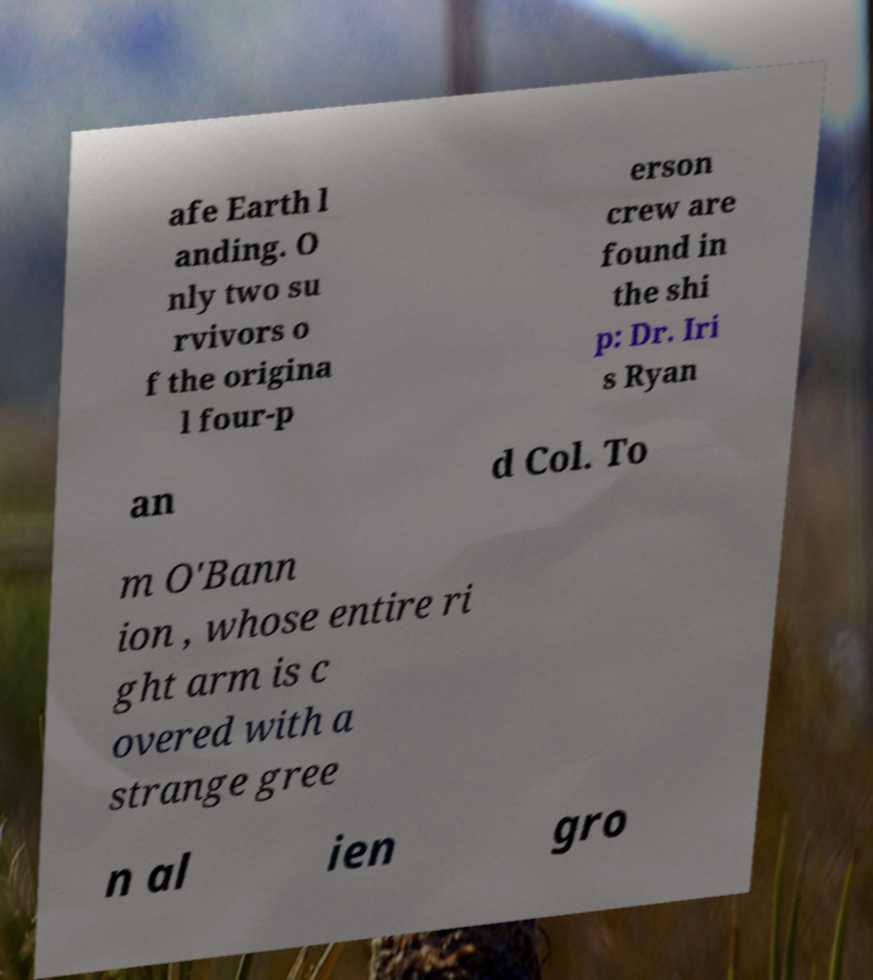Please identify and transcribe the text found in this image. afe Earth l anding. O nly two su rvivors o f the origina l four-p erson crew are found in the shi p: Dr. Iri s Ryan an d Col. To m O'Bann ion , whose entire ri ght arm is c overed with a strange gree n al ien gro 